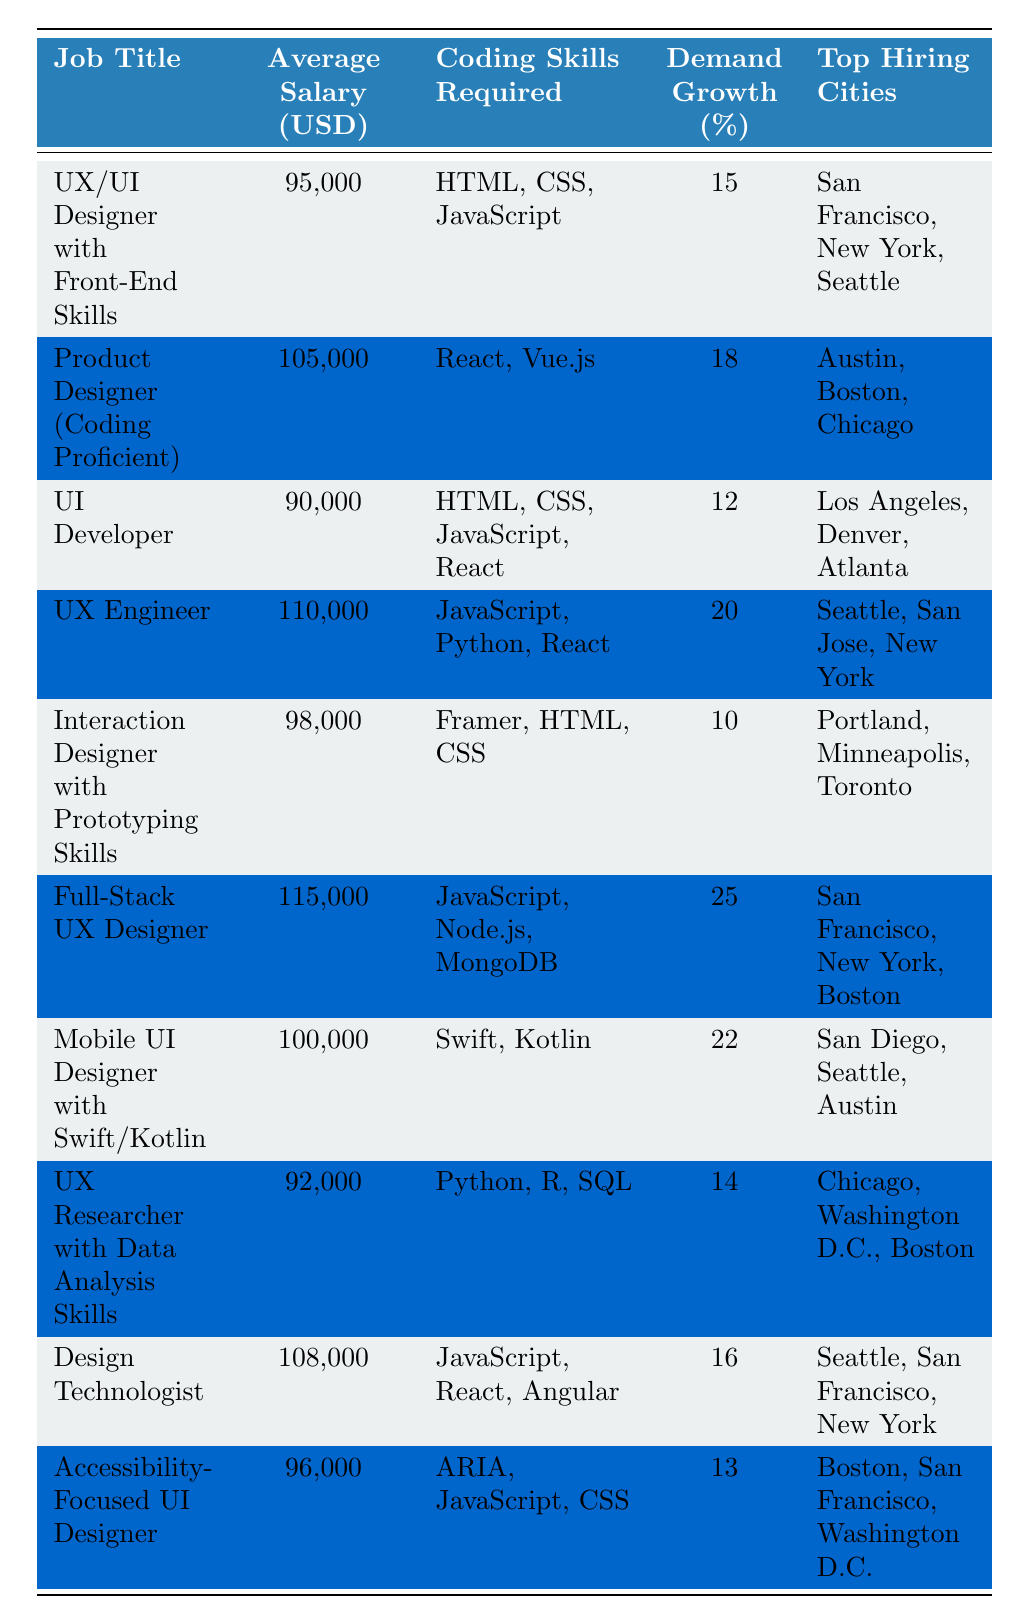What is the average salary of a Full-Stack UX Designer? The table shows the salary for a Full-Stack UX Designer as 115,000 USD.
Answer: 115,000 USD Which job has the highest demand growth percentage? Looking at the demand growth percentage, the Full-Stack UX Designer has the highest percentage at 25%.
Answer: Full-Stack UX Designer Is there a job title that requires Python as a coding skill? Yes, the UX Engineer and the UX Researcher both require Python as a coding skill.
Answer: Yes What are the top hiring cities for UX Engineers? The table lists Seattle, San Jose, and New York as the top hiring cities for UX Engineers.
Answer: Seattle, San Jose, New York How many job titles listed require JavaScript? The job titles requiring JavaScript are: UX/UI Designer with Front-End Skills, UI Developer, UX Engineer, Full-Stack UX Designer, Design Technologist, and Accessibility-Focused UI Designer. That's a total of 6 job titles.
Answer: 6 Which job has the lowest average salary, and what is it? The UI Developer has the lowest average salary at 90,000 USD.
Answer: 90,000 USD If we average the salaries of all job titles listed, what is the result? The sum of all listed salaries is 95,000 + 105,000 + 90,000 + 110,000 + 98,000 + 115,000 + 100,000 + 92,000 + 108,000 + 96,000 = 1,009,000 USD. There are 10 job titles, so the average salary is 1,009,000 / 10 = 100,900 USD.
Answer: 100,900 USD Which job title has the second highest salary, and which coding skills are required? The job title with the second highest salary is Product Designer (Coding Proficient) at 105,000 USD, requiring skills in React and Vue.js.
Answer: Product Designer (Coding Proficient), React, Vue.js Do any of the job titles require ARIA as a coding skill? Yes, one job title, the Accessibility-Focused UI Designer, requires ARIA.
Answer: Yes How does the average salary of jobs requiring Python compare to those that do not? The average salary of jobs requiring Python is (110,000 + 92,000) / 2 = 101,000 USD. For jobs not requiring Python, the average is (95,000 + 105,000 + 90,000 + 98,000 + 115,000 + 100,000 + 108,000 + 96,000) / 8 = 99,625 USD. Therefore, jobs requiring Python have a higher average salary by 1,375 USD.
Answer: Higher by 1,375 USD 